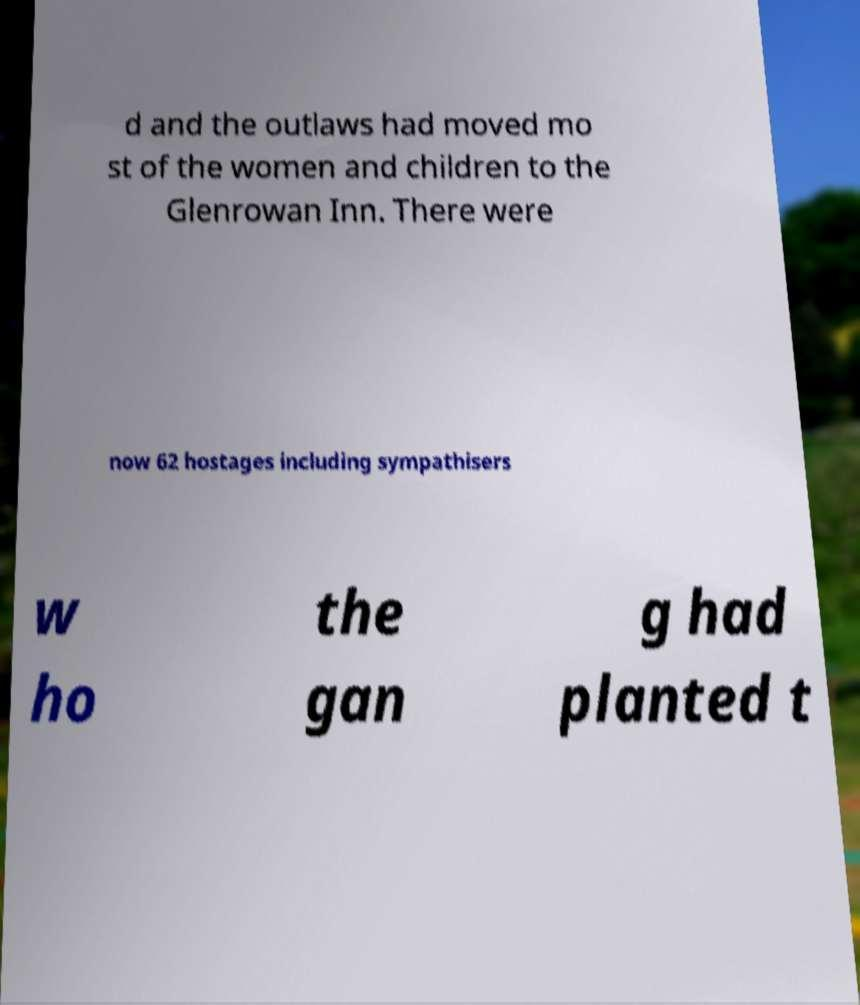What messages or text are displayed in this image? I need them in a readable, typed format. d and the outlaws had moved mo st of the women and children to the Glenrowan Inn. There were now 62 hostages including sympathisers w ho the gan g had planted t 